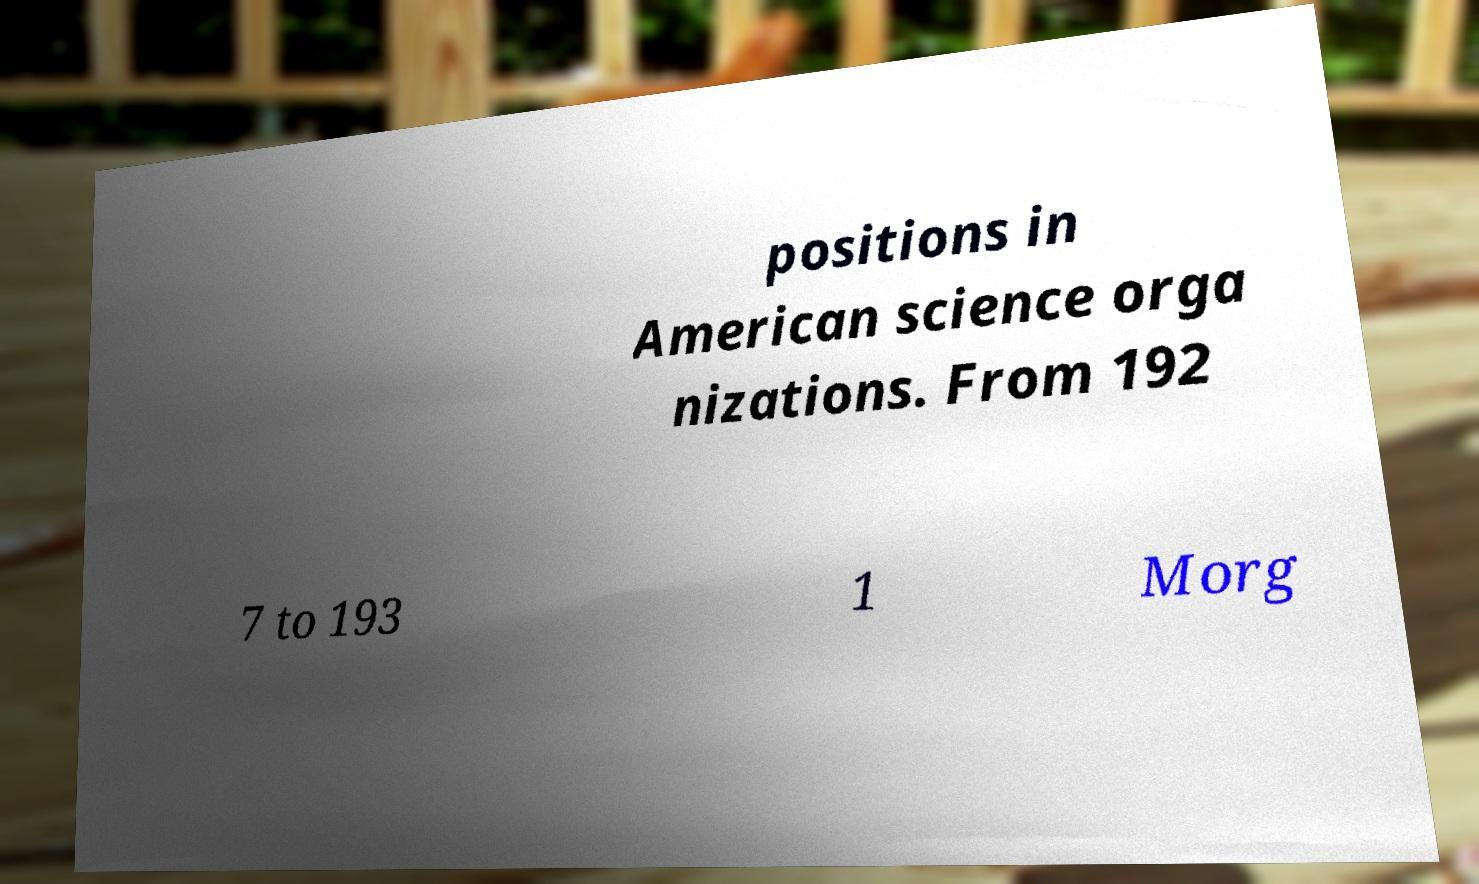Can you read and provide the text displayed in the image?This photo seems to have some interesting text. Can you extract and type it out for me? positions in American science orga nizations. From 192 7 to 193 1 Morg 